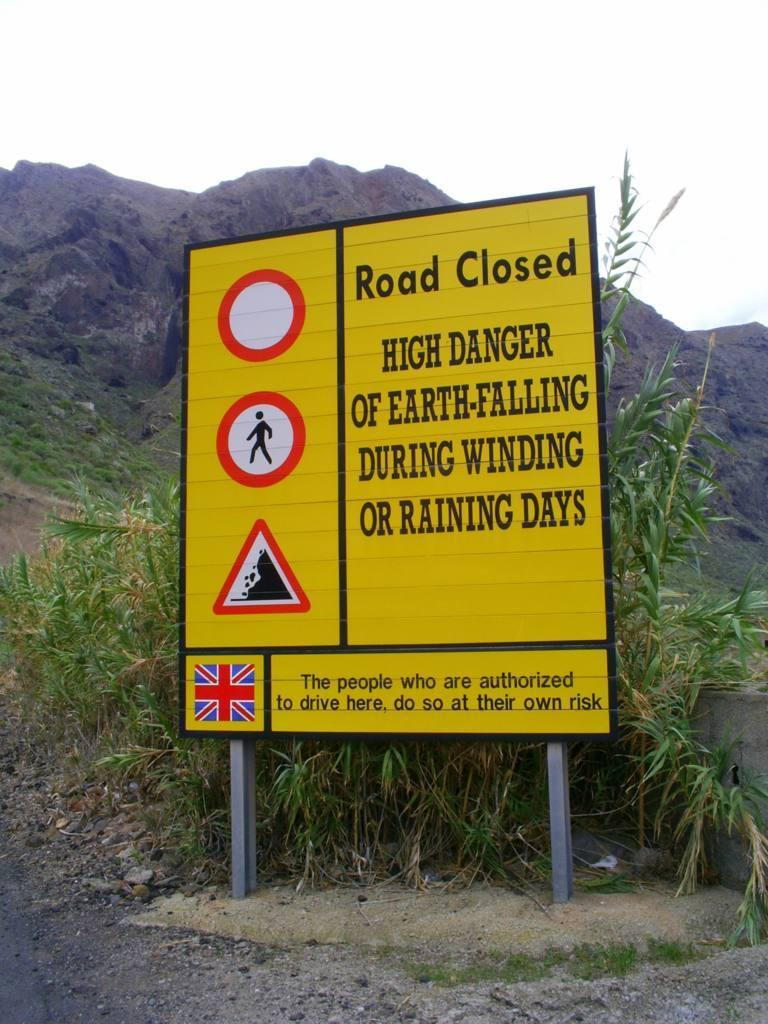Provide a one-sentence caption for the provided image. A road sign warns motorists of falling earth on windy and rainy days. 